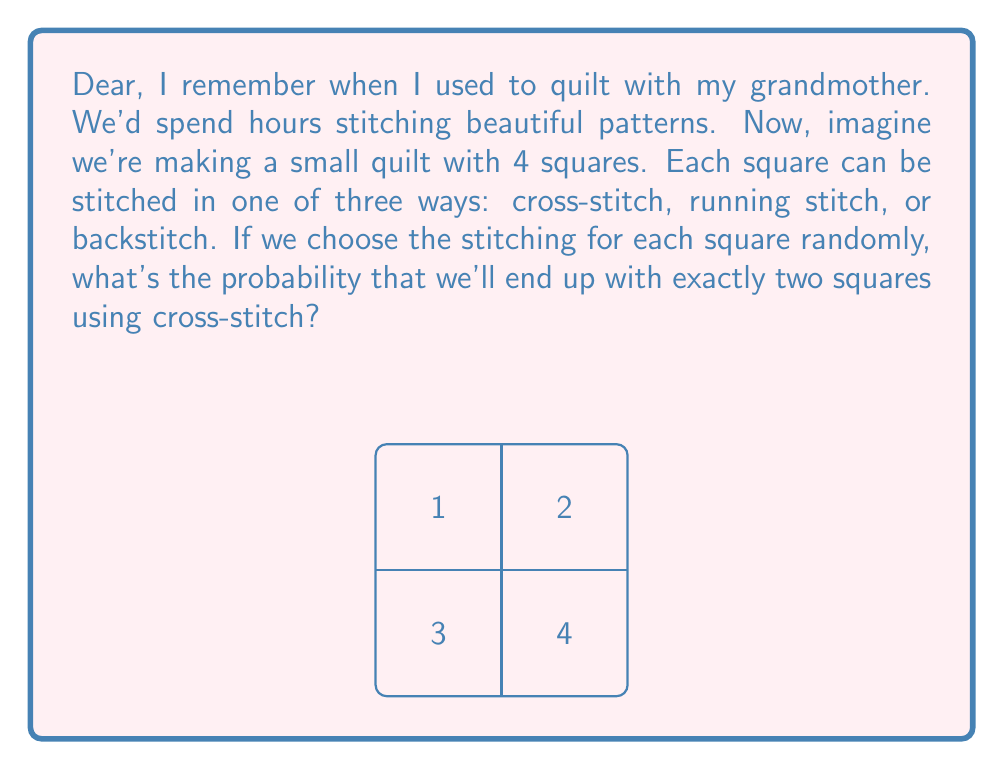Show me your answer to this math problem. Let's approach this step-by-step, dearie:

1) First, we need to understand what we're dealing with:
   - We have 4 squares
   - Each square has 3 possible stitching options
   - We want exactly 2 squares with cross-stitch

2) This is a binomial probability problem. We can use the formula:

   $$P(X = k) = \binom{n}{k} p^k (1-p)^{n-k}$$

   Where:
   $n$ = total number of squares (4)
   $k$ = number of squares we want with cross-stitch (2)
   $p$ = probability of choosing cross-stitch for any single square (1/3)

3) Let's plug in our values:

   $$P(X = 2) = \binom{4}{2} (\frac{1}{3})^2 (1-\frac{1}{3})^{4-2}$$

4) Now, let's calculate each part:
   - $\binom{4}{2} = 6$ (number of ways to choose 2 squares out of 4)
   - $(\frac{1}{3})^2 = \frac{1}{9}$ (probability of 2 cross-stitches)
   - $(1-\frac{1}{3})^2 = (\frac{2}{3})^2 = \frac{4}{9}$ (probability of 2 non-cross-stitches)

5) Putting it all together:

   $$P(X = 2) = 6 \cdot \frac{1}{9} \cdot \frac{4}{9} = \frac{24}{81} = \frac{8}{27}$$

So, the probability of having exactly two squares with cross-stitch is $\frac{8}{27}$.
Answer: $\frac{8}{27}$ 